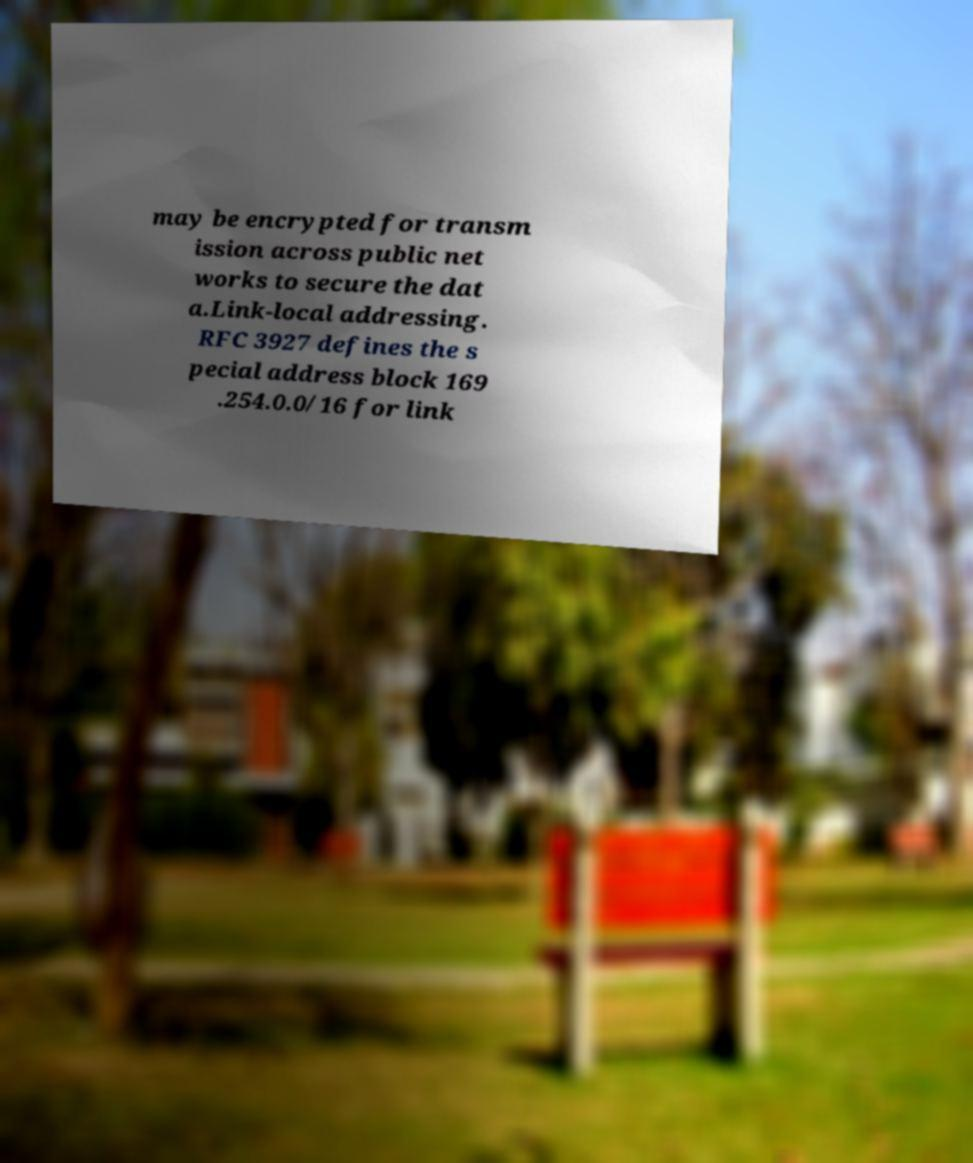Can you read and provide the text displayed in the image?This photo seems to have some interesting text. Can you extract and type it out for me? may be encrypted for transm ission across public net works to secure the dat a.Link-local addressing. RFC 3927 defines the s pecial address block 169 .254.0.0/16 for link 